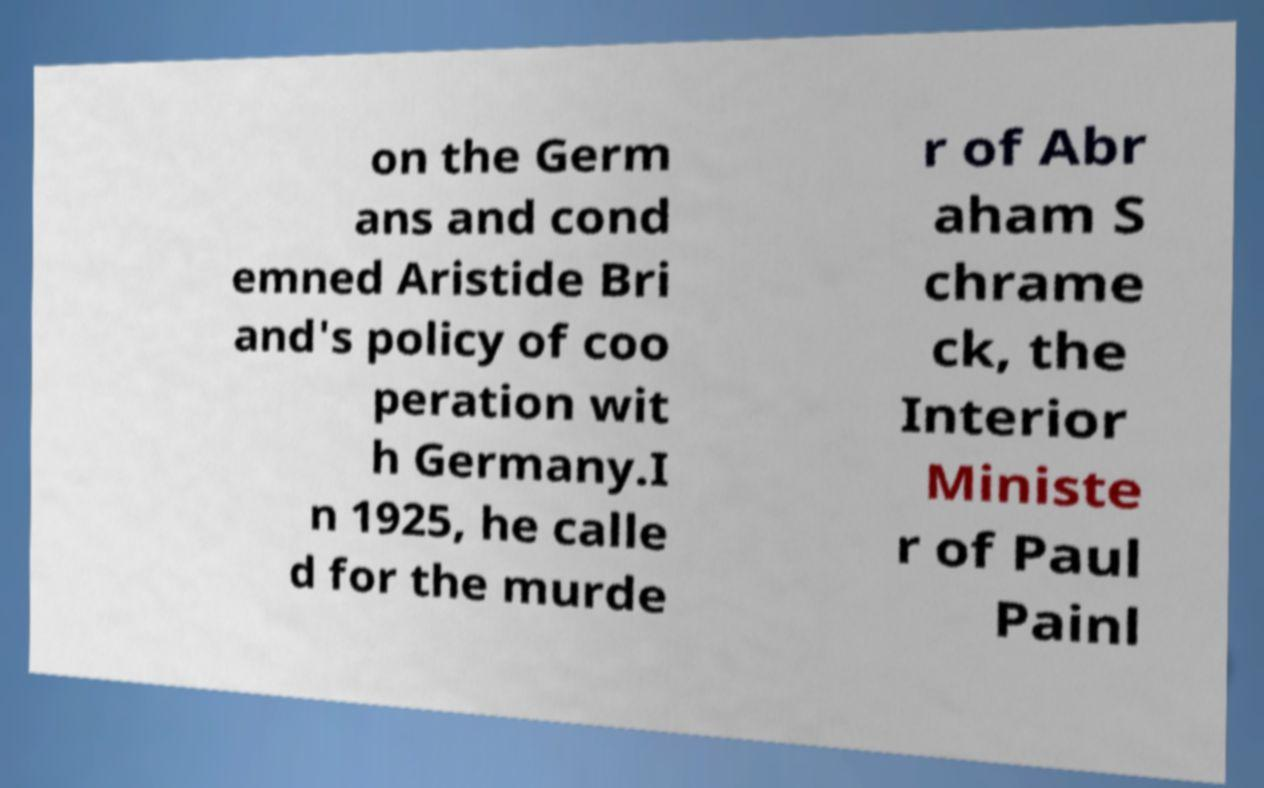I need the written content from this picture converted into text. Can you do that? on the Germ ans and cond emned Aristide Bri and's policy of coo peration wit h Germany.I n 1925, he calle d for the murde r of Abr aham S chrame ck, the Interior Ministe r of Paul Painl 